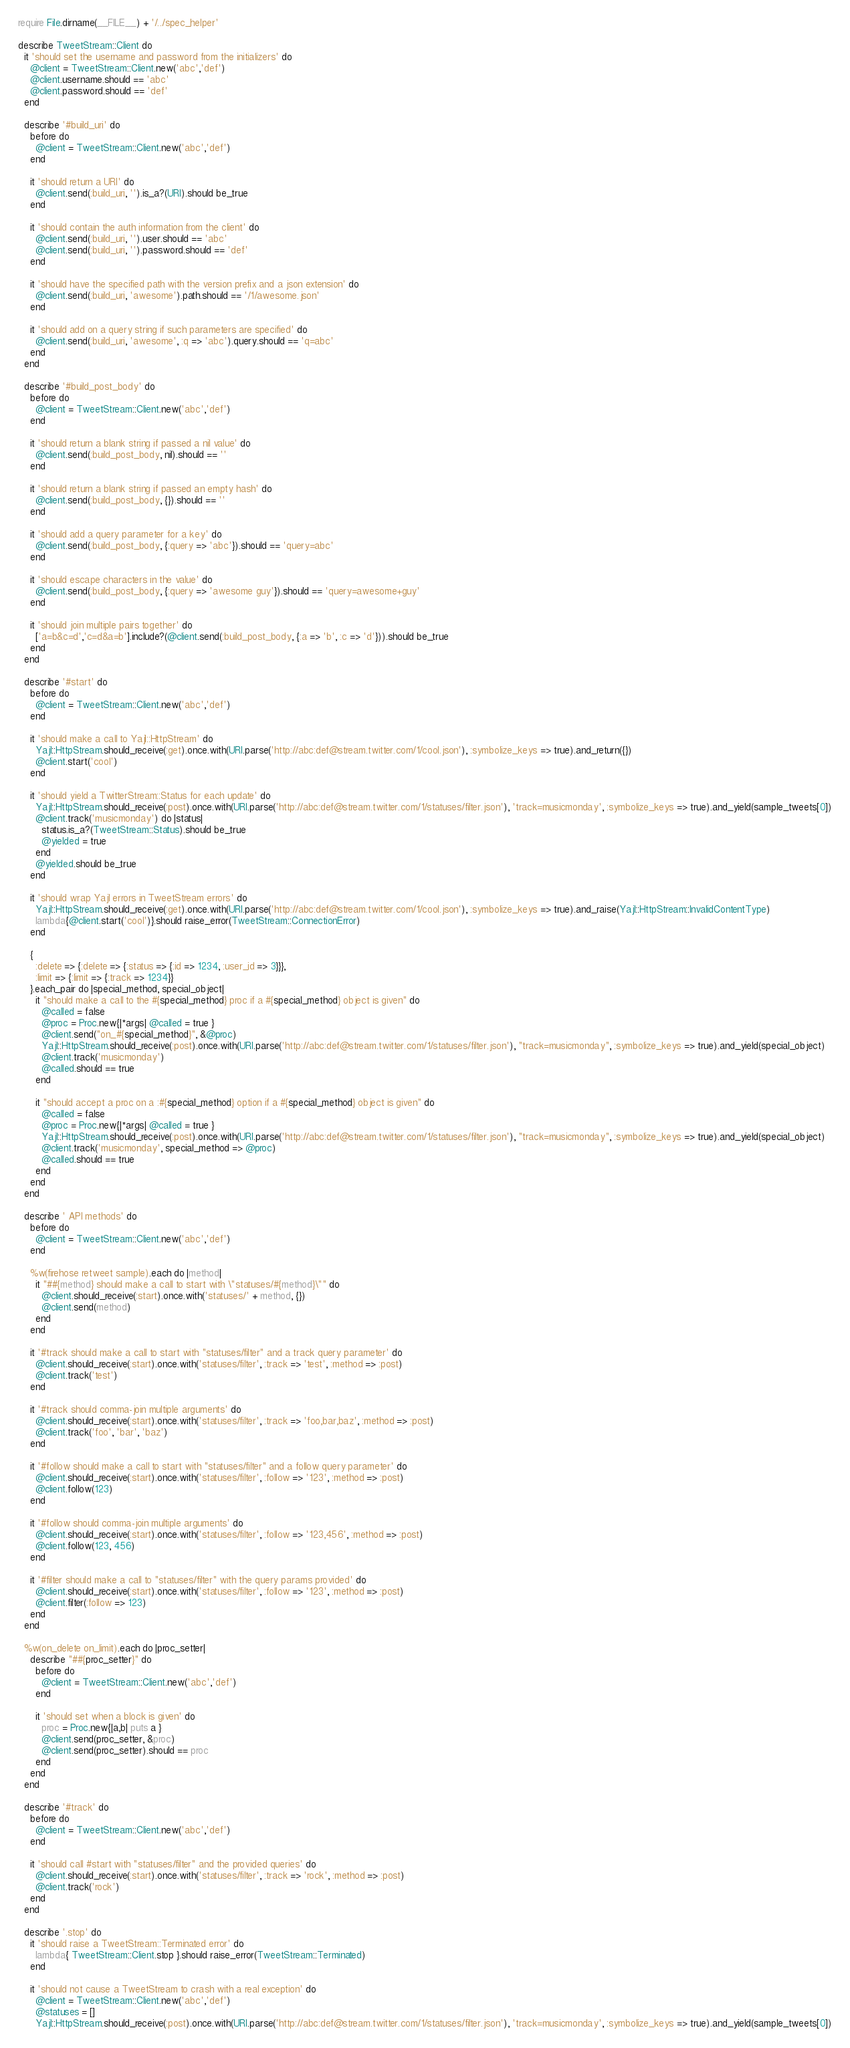<code> <loc_0><loc_0><loc_500><loc_500><_Ruby_>require File.dirname(__FILE__) + '/../spec_helper'

describe TweetStream::Client do
  it 'should set the username and password from the initializers' do
    @client = TweetStream::Client.new('abc','def')
    @client.username.should == 'abc'
    @client.password.should == 'def'
  end

  describe '#build_uri' do
    before do
      @client = TweetStream::Client.new('abc','def')
    end

    it 'should return a URI' do
      @client.send(:build_uri, '').is_a?(URI).should be_true
    end

    it 'should contain the auth information from the client' do
      @client.send(:build_uri, '').user.should == 'abc'
      @client.send(:build_uri, '').password.should == 'def'
    end

    it 'should have the specified path with the version prefix and a json extension' do
      @client.send(:build_uri, 'awesome').path.should == '/1/awesome.json'
    end

    it 'should add on a query string if such parameters are specified' do
      @client.send(:build_uri, 'awesome', :q => 'abc').query.should == 'q=abc'
    end
  end

  describe '#build_post_body' do
    before do
      @client = TweetStream::Client.new('abc','def')
    end
  
    it 'should return a blank string if passed a nil value' do
      @client.send(:build_post_body, nil).should == ''
    end

    it 'should return a blank string if passed an empty hash' do
      @client.send(:build_post_body, {}).should == ''
    end

    it 'should add a query parameter for a key' do
      @client.send(:build_post_body, {:query => 'abc'}).should == 'query=abc'
    end

    it 'should escape characters in the value' do
      @client.send(:build_post_body, {:query => 'awesome guy'}).should == 'query=awesome+guy'
    end

    it 'should join multiple pairs together' do
      ['a=b&c=d','c=d&a=b'].include?(@client.send(:build_post_body, {:a => 'b', :c => 'd'})).should be_true
    end
  end

  describe '#start' do
    before do
      @client = TweetStream::Client.new('abc','def')
    end

    it 'should make a call to Yajl::HttpStream' do
      Yajl::HttpStream.should_receive(:get).once.with(URI.parse('http://abc:def@stream.twitter.com/1/cool.json'), :symbolize_keys => true).and_return({})
      @client.start('cool')
    end

    it 'should yield a TwitterStream::Status for each update' do
      Yajl::HttpStream.should_receive(:post).once.with(URI.parse('http://abc:def@stream.twitter.com/1/statuses/filter.json'), 'track=musicmonday', :symbolize_keys => true).and_yield(sample_tweets[0])
      @client.track('musicmonday') do |status|
        status.is_a?(TweetStream::Status).should be_true
        @yielded = true
      end
      @yielded.should be_true
    end
    
    it 'should wrap Yajl errors in TweetStream errors' do
      Yajl::HttpStream.should_receive(:get).once.with(URI.parse('http://abc:def@stream.twitter.com/1/cool.json'), :symbolize_keys => true).and_raise(Yajl::HttpStream::InvalidContentType)
      lambda{@client.start('cool')}.should raise_error(TweetStream::ConnectionError)
    end
    
    {
      :delete => {:delete => {:status => {:id => 1234, :user_id => 3}}},
      :limit => {:limit => {:track => 1234}}
    }.each_pair do |special_method, special_object|
      it "should make a call to the #{special_method} proc if a #{special_method} object is given" do
        @called = false
        @proc = Proc.new{|*args| @called = true }
        @client.send("on_#{special_method}", &@proc)
        Yajl::HttpStream.should_receive(:post).once.with(URI.parse('http://abc:def@stream.twitter.com/1/statuses/filter.json'), "track=musicmonday", :symbolize_keys => true).and_yield(special_object)
        @client.track('musicmonday')
        @called.should == true
      end
      
      it "should accept a proc on a :#{special_method} option if a #{special_method} object is given" do
        @called = false
        @proc = Proc.new{|*args| @called = true }
        Yajl::HttpStream.should_receive(:post).once.with(URI.parse('http://abc:def@stream.twitter.com/1/statuses/filter.json'), "track=musicmonday", :symbolize_keys => true).and_yield(special_object)
        @client.track('musicmonday', special_method => @proc)
        @called.should == true
      end
    end
  end
  
  describe ' API methods' do
    before do
      @client = TweetStream::Client.new('abc','def')
    end
    
    %w(firehose retweet sample).each do |method|
      it "##{method} should make a call to start with \"statuses/#{method}\"" do
        @client.should_receive(:start).once.with('statuses/' + method, {})
        @client.send(method)
      end
    end
    
    it '#track should make a call to start with "statuses/filter" and a track query parameter' do
      @client.should_receive(:start).once.with('statuses/filter', :track => 'test', :method => :post)
      @client.track('test')
    end
    
    it '#track should comma-join multiple arguments' do
      @client.should_receive(:start).once.with('statuses/filter', :track => 'foo,bar,baz', :method => :post)
      @client.track('foo', 'bar', 'baz')
    end
    
    it '#follow should make a call to start with "statuses/filter" and a follow query parameter' do
      @client.should_receive(:start).once.with('statuses/filter', :follow => '123', :method => :post)
      @client.follow(123)
    end
    
    it '#follow should comma-join multiple arguments' do
      @client.should_receive(:start).once.with('statuses/filter', :follow => '123,456', :method => :post)
      @client.follow(123, 456)
    end
    
    it '#filter should make a call to "statuses/filter" with the query params provided' do
      @client.should_receive(:start).once.with('statuses/filter', :follow => '123', :method => :post)
      @client.filter(:follow => 123)
    end
  end
  
  %w(on_delete on_limit).each do |proc_setter|
    describe "##{proc_setter}" do
      before do
        @client = TweetStream::Client.new('abc','def')
      end
      
      it 'should set when a block is given' do
        proc = Proc.new{|a,b| puts a }
        @client.send(proc_setter, &proc)
        @client.send(proc_setter).should == proc
      end
    end
  end

  describe '#track' do
    before do
      @client = TweetStream::Client.new('abc','def')
    end

    it 'should call #start with "statuses/filter" and the provided queries' do
      @client.should_receive(:start).once.with('statuses/filter', :track => 'rock', :method => :post)
      @client.track('rock')
    end
  end
  
  describe '.stop' do
    it 'should raise a TweetStream::Terminated error' do
      lambda{ TweetStream::Client.stop }.should raise_error(TweetStream::Terminated)
    end
    
    it 'should not cause a TweetStream to crash with a real exception' do
      @client = TweetStream::Client.new('abc','def')
      @statuses = []
      Yajl::HttpStream.should_receive(:post).once.with(URI.parse('http://abc:def@stream.twitter.com/1/statuses/filter.json'), 'track=musicmonday', :symbolize_keys => true).and_yield(sample_tweets[0])</code> 